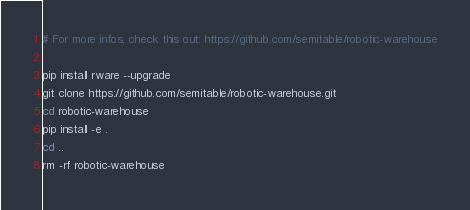Convert code to text. <code><loc_0><loc_0><loc_500><loc_500><_Bash_># For more infos, check this out: https://github.com/semitable/robotic-warehouse

pip install rware --upgrade
git clone https://github.com/semitable/robotic-warehouse.git
cd robotic-warehouse
pip install -e .
cd ..
rm -rf robotic-warehouse</code> 